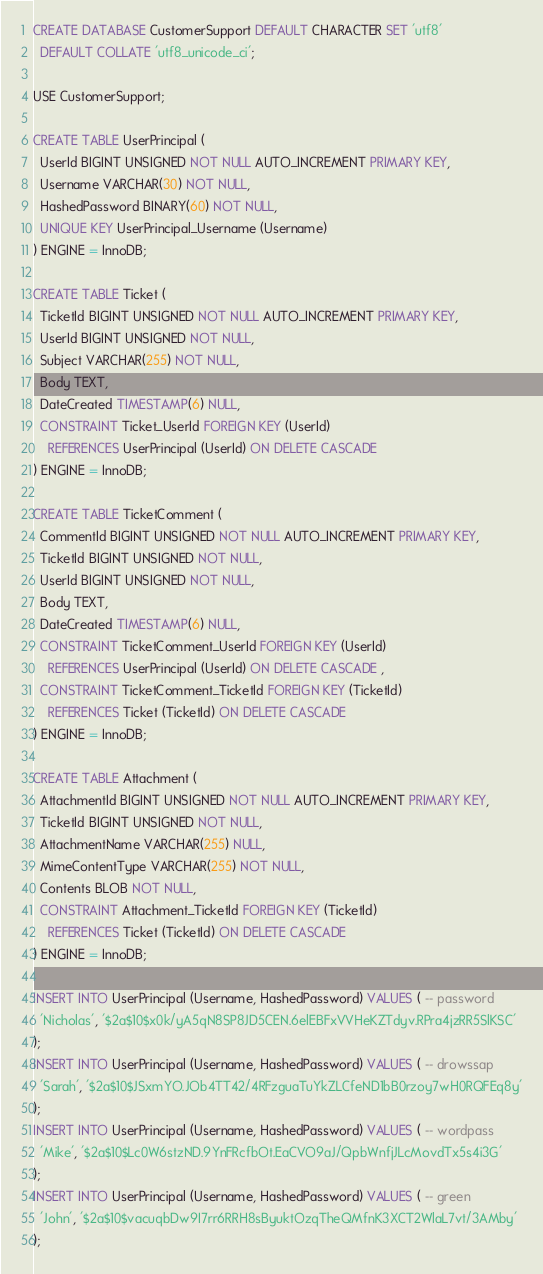Convert code to text. <code><loc_0><loc_0><loc_500><loc_500><_SQL_>CREATE DATABASE CustomerSupport DEFAULT CHARACTER SET 'utf8'
  DEFAULT COLLATE 'utf8_unicode_ci';

USE CustomerSupport;

CREATE TABLE UserPrincipal (
  UserId BIGINT UNSIGNED NOT NULL AUTO_INCREMENT PRIMARY KEY,
  Username VARCHAR(30) NOT NULL,
  HashedPassword BINARY(60) NOT NULL,
  UNIQUE KEY UserPrincipal_Username (Username)
) ENGINE = InnoDB;

CREATE TABLE Ticket (
  TicketId BIGINT UNSIGNED NOT NULL AUTO_INCREMENT PRIMARY KEY,
  UserId BIGINT UNSIGNED NOT NULL,
  Subject VARCHAR(255) NOT NULL,
  Body TEXT,
  DateCreated TIMESTAMP(6) NULL,
  CONSTRAINT Ticket_UserId FOREIGN KEY (UserId)
    REFERENCES UserPrincipal (UserId) ON DELETE CASCADE
) ENGINE = InnoDB;

CREATE TABLE TicketComment (
  CommentId BIGINT UNSIGNED NOT NULL AUTO_INCREMENT PRIMARY KEY,
  TicketId BIGINT UNSIGNED NOT NULL,
  UserId BIGINT UNSIGNED NOT NULL,
  Body TEXT,
  DateCreated TIMESTAMP(6) NULL,
  CONSTRAINT TicketComment_UserId FOREIGN KEY (UserId)
    REFERENCES UserPrincipal (UserId) ON DELETE CASCADE ,
  CONSTRAINT TicketComment_TicketId FOREIGN KEY (TicketId)
    REFERENCES Ticket (TicketId) ON DELETE CASCADE
) ENGINE = InnoDB;

CREATE TABLE Attachment (
  AttachmentId BIGINT UNSIGNED NOT NULL AUTO_INCREMENT PRIMARY KEY,
  TicketId BIGINT UNSIGNED NOT NULL,
  AttachmentName VARCHAR(255) NULL,
  MimeContentType VARCHAR(255) NOT NULL,
  Contents BLOB NOT NULL,
  CONSTRAINT Attachment_TicketId FOREIGN KEY (TicketId)
    REFERENCES Ticket (TicketId) ON DELETE CASCADE
) ENGINE = InnoDB;

INSERT INTO UserPrincipal (Username, HashedPassword) VALUES ( -- password
  'Nicholas', '$2a$10$x0k/yA5qN8SP8JD5CEN.6elEBFxVVHeKZTdyv.RPra4jzRR5SlKSC'
);
INSERT INTO UserPrincipal (Username, HashedPassword) VALUES ( -- drowssap
  'Sarah', '$2a$10$JSxmYO.JOb4TT42/4RFzguaTuYkZLCfeND1bB0rzoy7wH0RQFEq8y'
);
INSERT INTO UserPrincipal (Username, HashedPassword) VALUES ( -- wordpass
  'Mike', '$2a$10$Lc0W6stzND.9YnFRcfbOt.EaCVO9aJ/QpbWnfjJLcMovdTx5s4i3G'
);
INSERT INTO UserPrincipal (Username, HashedPassword) VALUES ( -- green
  'John', '$2a$10$vacuqbDw9I7rr6RRH8sByuktOzqTheQMfnK3XCT2WlaL7vt/3AMby'
);
</code> 